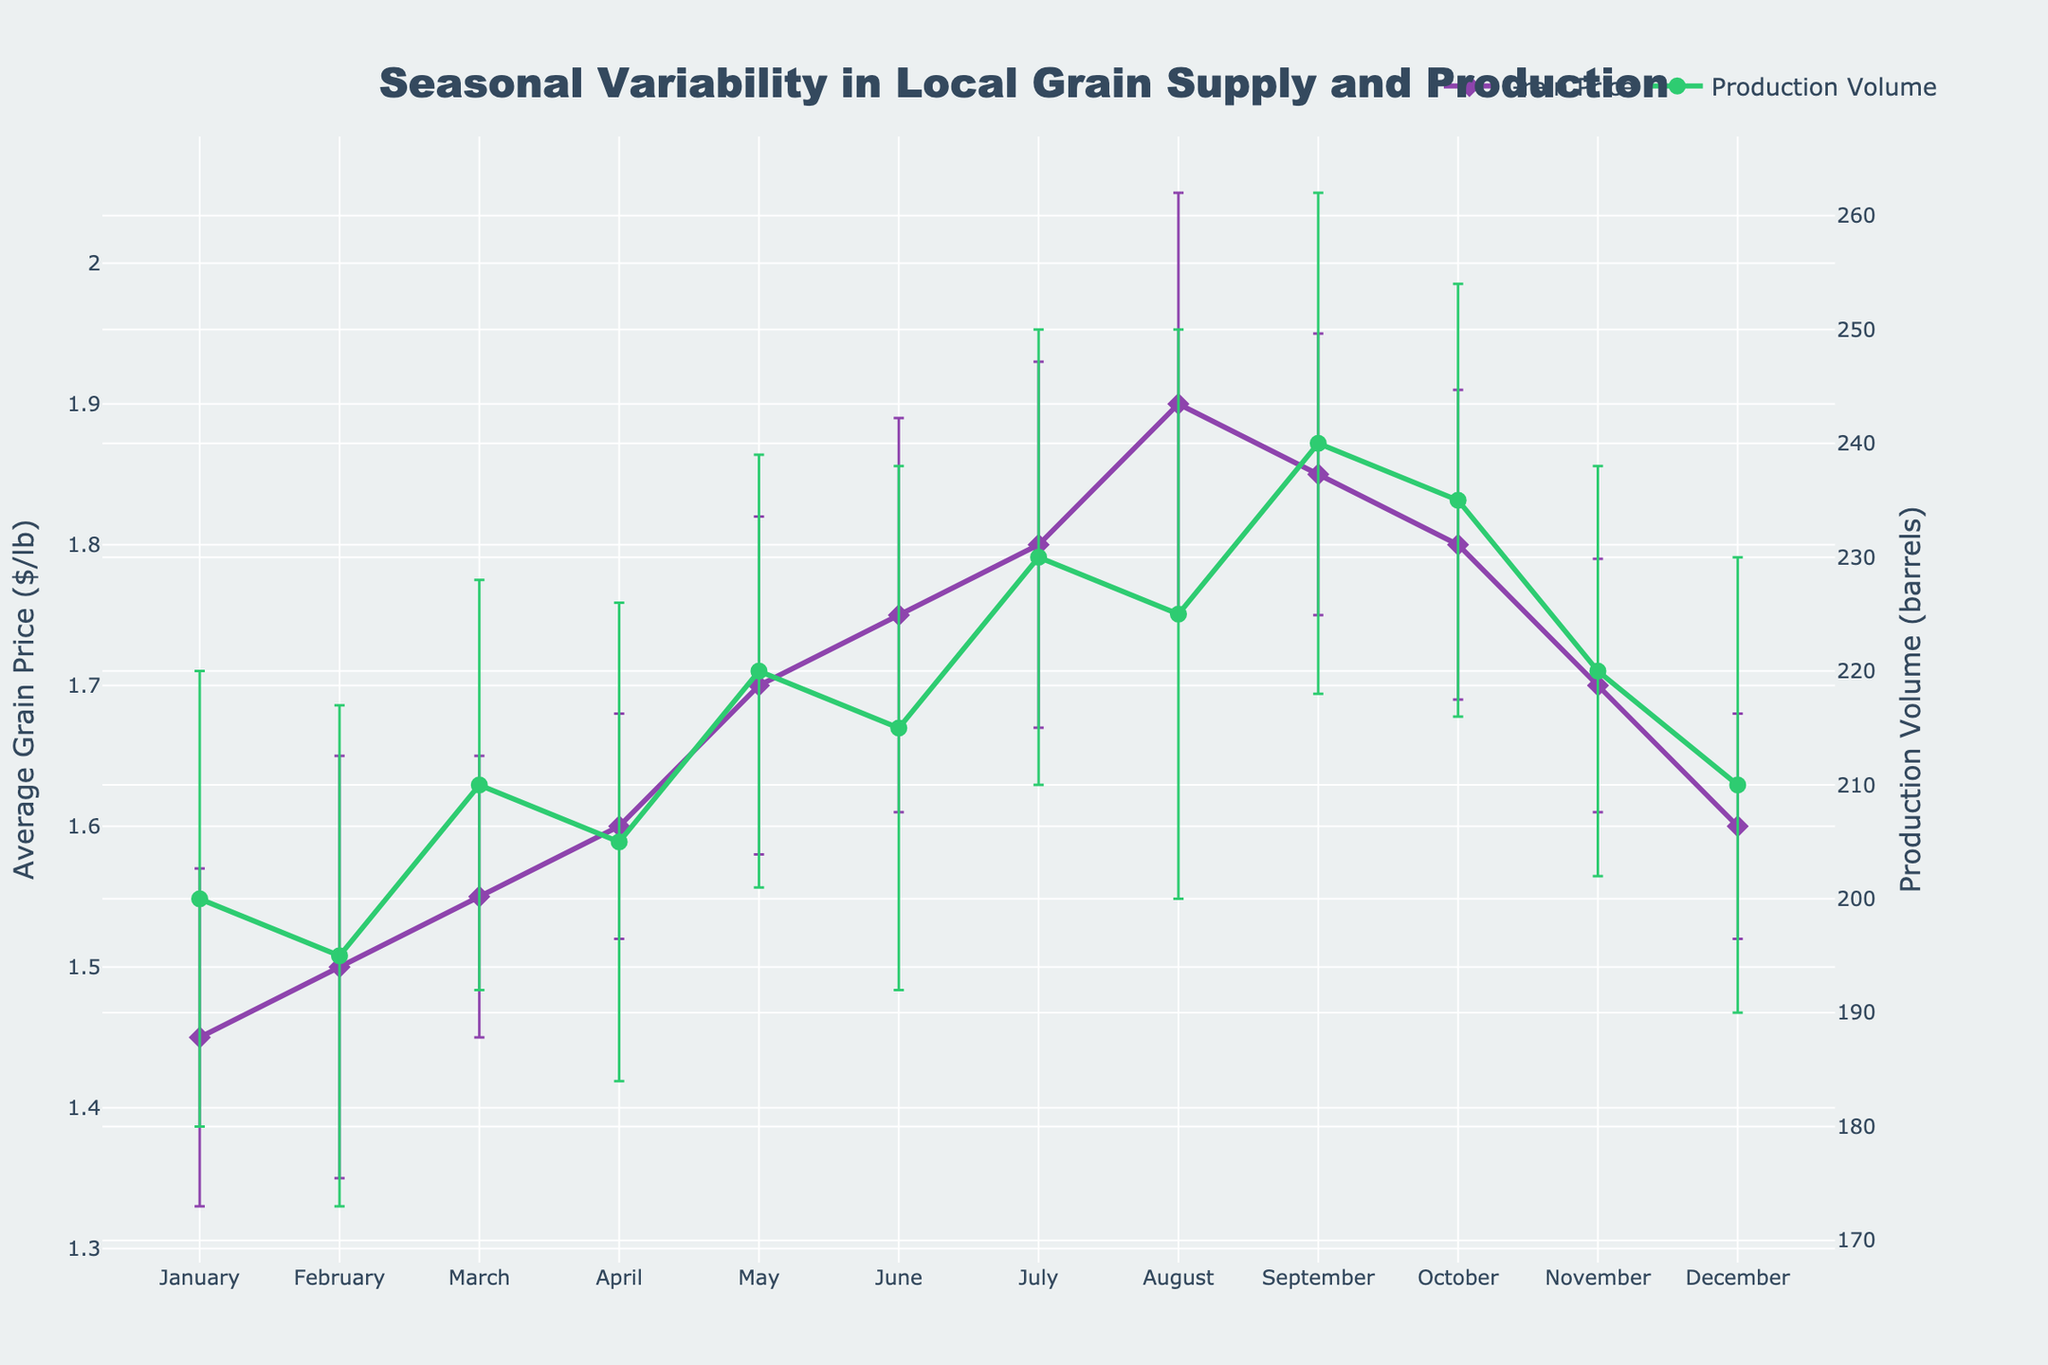What's the title of the plot? The title of the plot is found at the center and top of the figure. It reads "Seasonal Variability in Local Grain Supply and Production" in a large, bold font.
Answer: "Seasonal Variability in Local Grain Supply and Production" What months show the highest and lowest average grain prices? To find this, look at the peaks and troughs of the purple line representing the average grain price through the months. The highest price appears in August at $1.90/lb, and the lowest price is in January at $1.45/lb.
Answer: August and January What is the difference in production volume between March and September? Identify the production volumes for March (210 barrels) and September (240 barrels) from the green line. Subtract the March value from the September value: 240 - 210 = 30 barrels.
Answer: 30 barrels Which month had the highest production volume and what was its value? The peak of the green line representing production volume indicates the highest point. This occurs in September with a value of 240 barrels.
Answer: September, 240 barrels How does the production volume trend correlate with grain price over the months? To analyze correlation, observe both lines together. While grain prices generally increase until August then slightly decrease, production volume increases with some fluctuations but follows a somewhat similar trend with a peak in September slightly after the grain price peak.
Answer: Positive correlation with some lag What is the average grain price for the first quarter of the year (January to March)? Calculate the average of the grain prices for January ($1.45), February ($1.50), and March ($1.55): (1.45 + 1.50 + 1.55)/3 = $1.50.
Answer: $1.50 What months had a decrease in production volume compared to the previous month? Compare each month’s value on the green line to the previous month’s value. Decreases are seen from January to February (200 to 195 barrels), April to May (205 to 220 barrels), and October to November (235 to 220 barrels).
Answer: February, May, November What's the range of average grain prices over the year? Identify the minimum and maximum grain prices from the purple line: $1.45 (January) to $1.90 (August). The range is 1.90 - 1.45 = $0.45.
Answer: $0.45 What is the standard deviation of the production volume in June? Look at June's production volume error bar. The standard deviation for the production volume in June is 23 barrels, displayed as an error bar extending from the value shown on the green line.
Answer: 23 barrels 